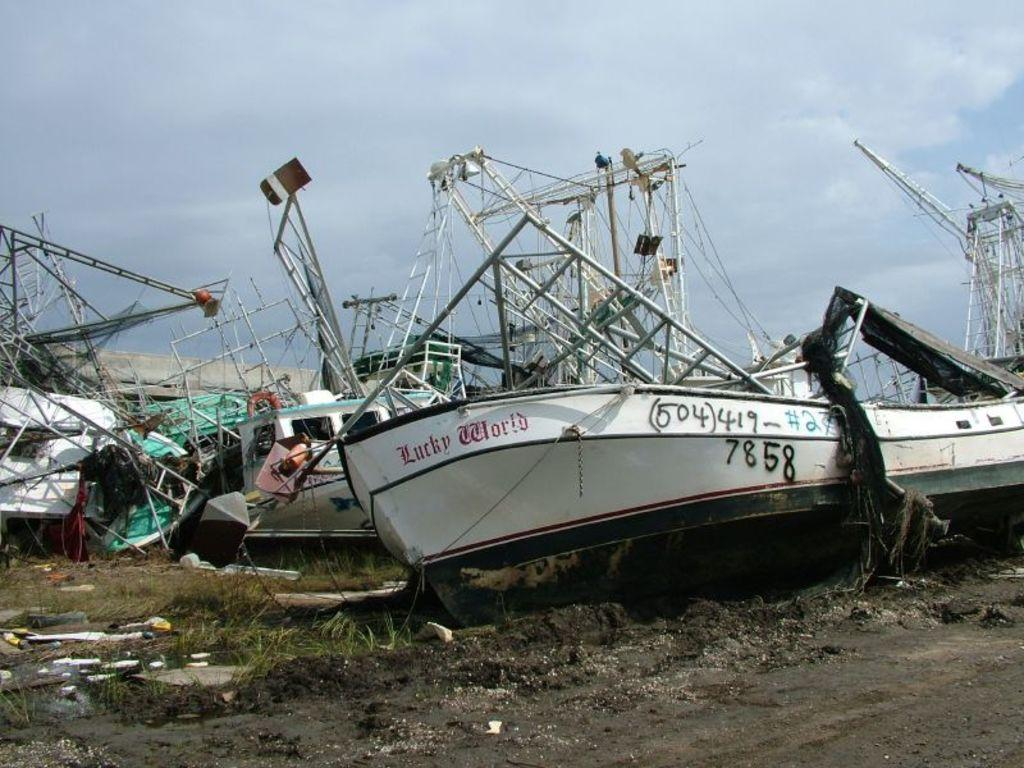What type of vehicles are on the ground in the image? There are boats on the ground in the image. What is the texture of the ground? The ground has grass. What can be seen in the sky in the background of the image? There are clouds in the sky in the background. What type of baseball equipment can be seen in the image? There is no baseball equipment present in the image. What type of cart is used to transport the boats in the image? There is no cart present in the image; the boats are on the ground. 